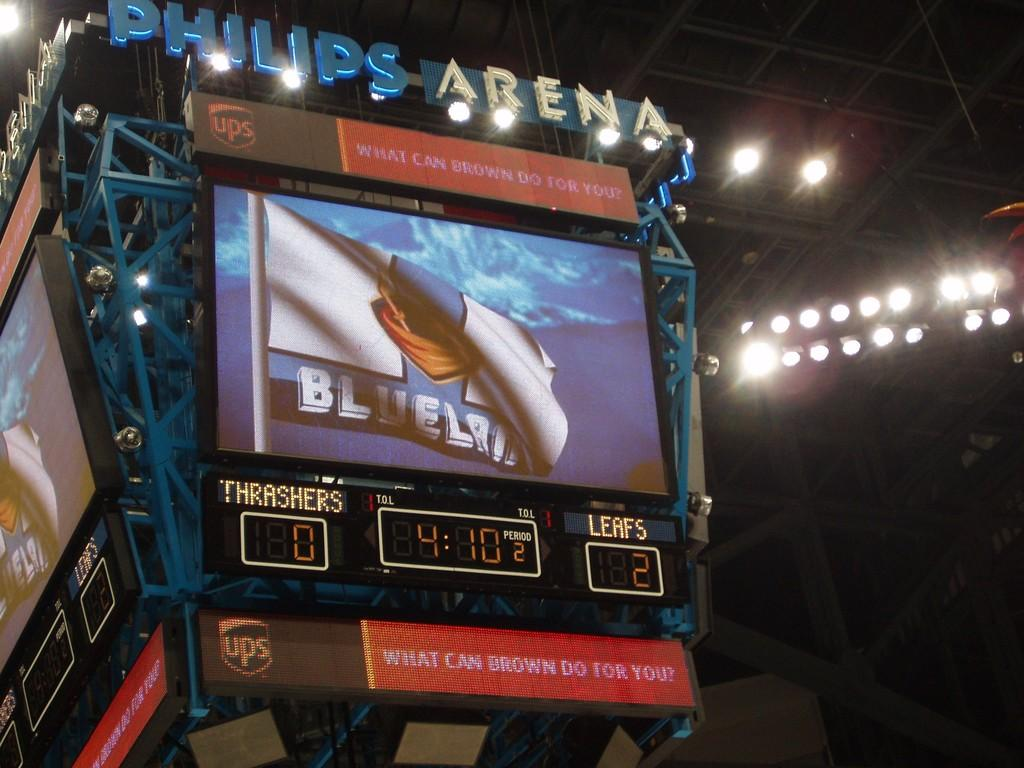<image>
Relay a brief, clear account of the picture shown. The score board at the Philips Arena shoes the Thrashers have 0 and the Leafs have 2 points. 